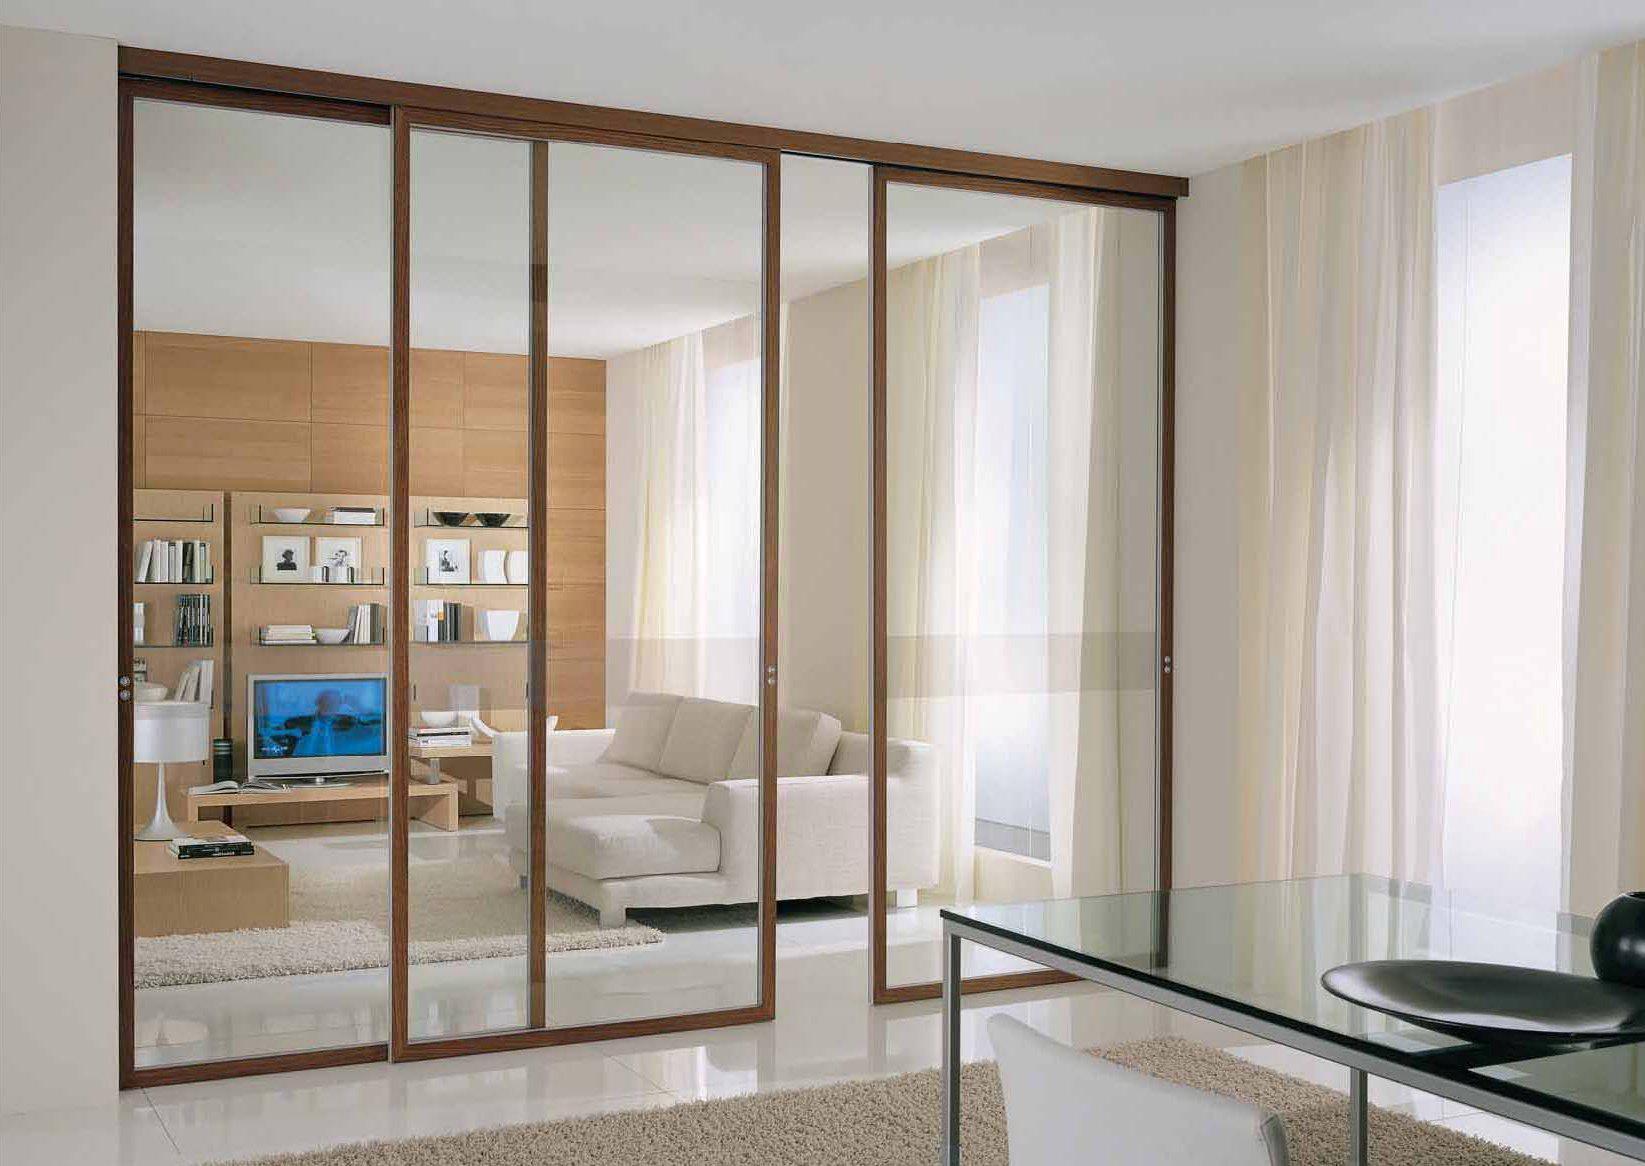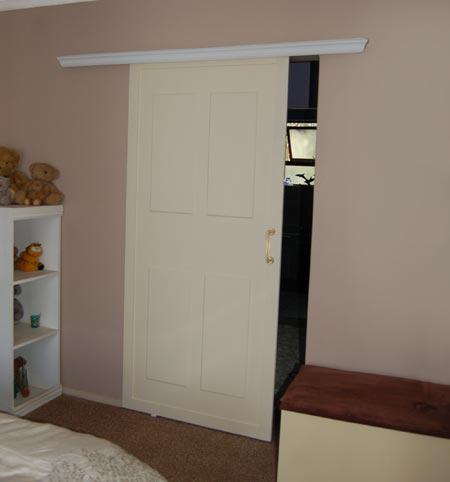The first image is the image on the left, the second image is the image on the right. Examine the images to the left and right. Is the description "In at least one image there is a single hanging door on a track." accurate? Answer yes or no. Yes. The first image is the image on the left, the second image is the image on the right. For the images displayed, is the sentence "One door is solid wood." factually correct? Answer yes or no. Yes. 